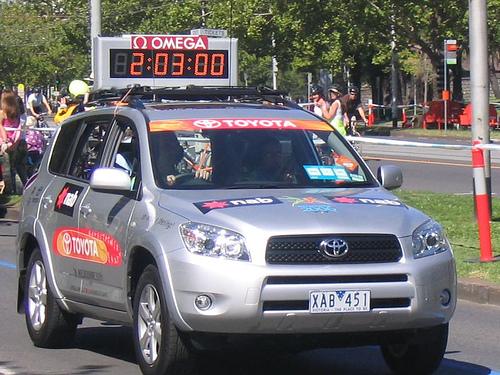What is the time?
Short answer required. 2:03. What brand is the vehicle?
Short answer required. Toyota. What is this machine?
Be succinct. Car. What letter is on the front of the car?
Answer briefly. Xab. What kind of clock is shown?
Keep it brief. Digital. 